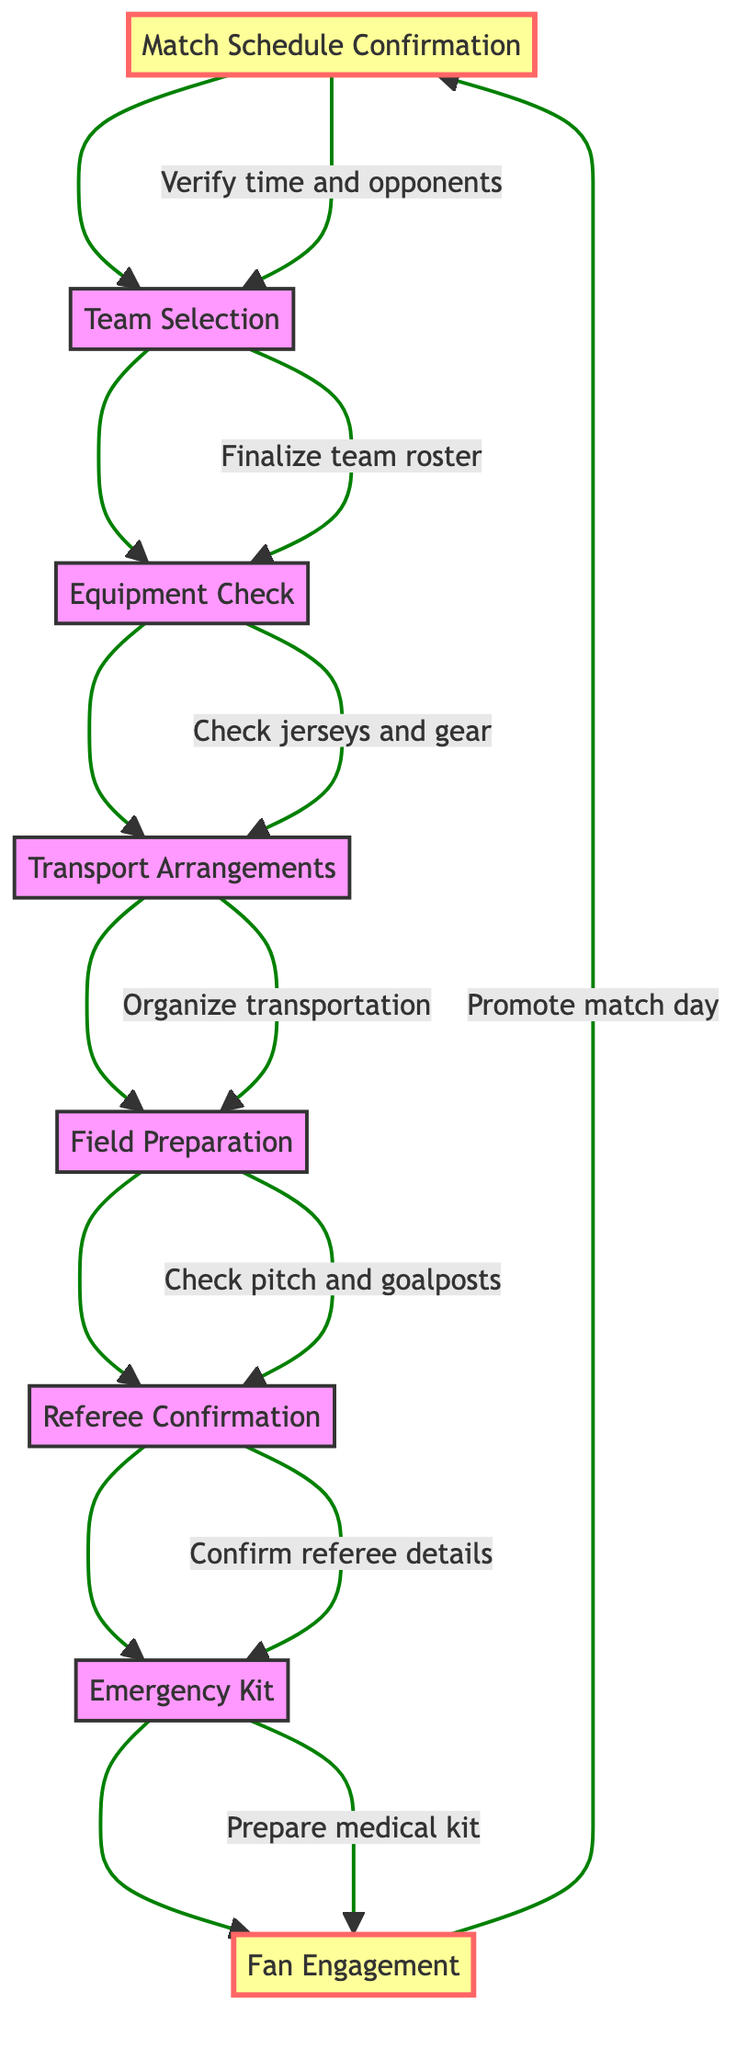What is the first step in the preparation checklist? The first step listed in the flowchart is "Match Schedule Confirmation." It is the starting point of the flow and indicates that this step must be completed before moving to the next.
Answer: Match Schedule Confirmation How many steps are in the checklist? The diagram lists a total of eight steps, starting from "Match Schedule Confirmation" and ending with "Fan Engagement." Counting each node will confirm this total.
Answer: 8 What action follows "Field Preparation"? According to the flow, the step that comes after "Field Preparation" is "Referee Confirmation." The flow directly links these two steps in sequence.
Answer: Referee Confirmation What action is associated with "Equipment Check"? The action corresponding to "Equipment Check" is "Ensure jerseys, shorts, socks, and gear are available." Each step in the flowchart has a specific action listed next to it.
Answer: Ensure jerseys, shorts, socks, and gear are available Which step emphasizes engaging with fans? The final step in the flowchart is "Fan Engagement," which focuses on promoting match day activities and encouraging attendance among supporters. Looking at the last node gives this information.
Answer: Fan Engagement What relationship exists between "Team Selection" and "Equipment Check"? "Team Selection" leads into "Equipment Check" in the flowchart, showing a sequential relationship where completing the team selection is necessary before checking the equipment.
Answer: Sequential relationship How many total actions are mentioned in the diagram? There are a total of eight actions mentioned in the flowchart, each corresponding to the eight steps outlined. Counting the individual actions confirms this total.
Answer: 8 What is the last step before the match day activities draw to a close? The last step before the flow returns to the start is "Fan Engagement," indicating that there is a focus on fan involvement even towards the end of the checklist.
Answer: Fan Engagement 